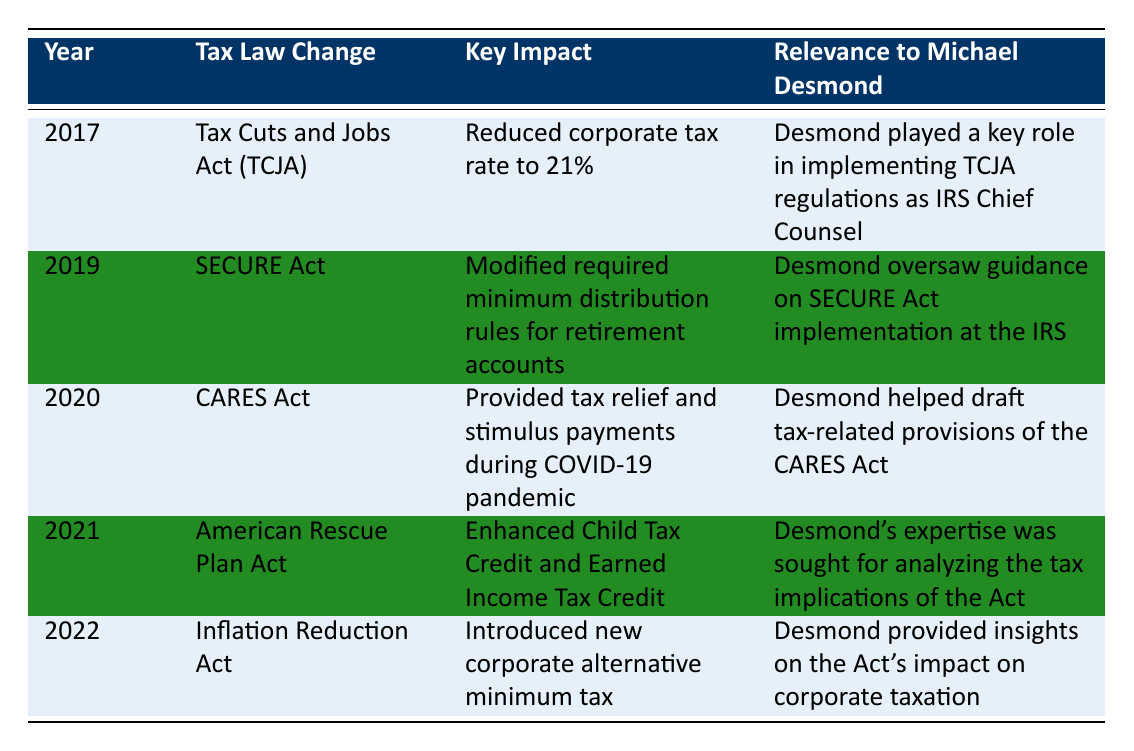What tax law change occurred in 2017? Referring to the table, the row for the year 2017 shows "Tax Cuts and Jobs Act (TCJA)" under the "Tax Law Change" column.
Answer: Tax Cuts and Jobs Act (TCJA) What was the key impact of the SECURE Act? In the table, the "Key Impact" column for the SECURE Act indicates it modified required minimum distribution rules for retirement accounts.
Answer: Modified required minimum distribution rules for retirement accounts Did Michael Desmond play a role in the implementation of the CARES Act? The table states that Desmond helped draft tax-related provisions of the CARES Act, indicating his involvement.
Answer: Yes How many of the tax law changes mentioned enhanced tax credits for individuals? Reviewing the table, the American Rescue Plan Act enhanced Child Tax Credit and Earned Income Tax Credit in 2021, meaning there is only one relevant entry.
Answer: 1 Which tax law changes occurred after 2019? From the table, the tax law changes after 2019 include the CARES Act (2020), American Rescue Plan Act (2021), and Inflation Reduction Act (2022). There are three entries total.
Answer: 3 What was the primary focus of the Inflation Reduction Act? The column for "Key Impact" in the row for the Inflation Reduction Act indicates it introduced a new corporate alternative minimum tax.
Answer: Introduced new corporate alternative minimum tax Was there a tax law change related to retirement accounts before 2021? The SECURE Act in 2019 modified required minimum distribution rules for retirement accounts, confirming a related change existed before 2021.
Answer: Yes Which tax law change's implementation did Desmond oversee at the IRS? The SECURE Act's implementation is noted specifically in the table under Desmond's relevance, showing he oversaw its guidance.
Answer: SECURE Act What were the years when corporate tax changes were implemented? Consulting the table, the TCJA in 2017 reduced corporate tax rates, and the Inflation Reduction Act in 2022 introduced a new corporate alternative minimum tax. The years are 2017 and 2022.
Answer: 2017 and 2022 How did the tax relief during the COVID-19 pandemic manifest according to the CARES Act? The CARES Act, as noted in the table, provided tax relief and stimulus payments, which indicates a direct connection to helping individuals financially during the pandemic.
Answer: Tax relief and stimulus payments during COVID-19 pandemic 